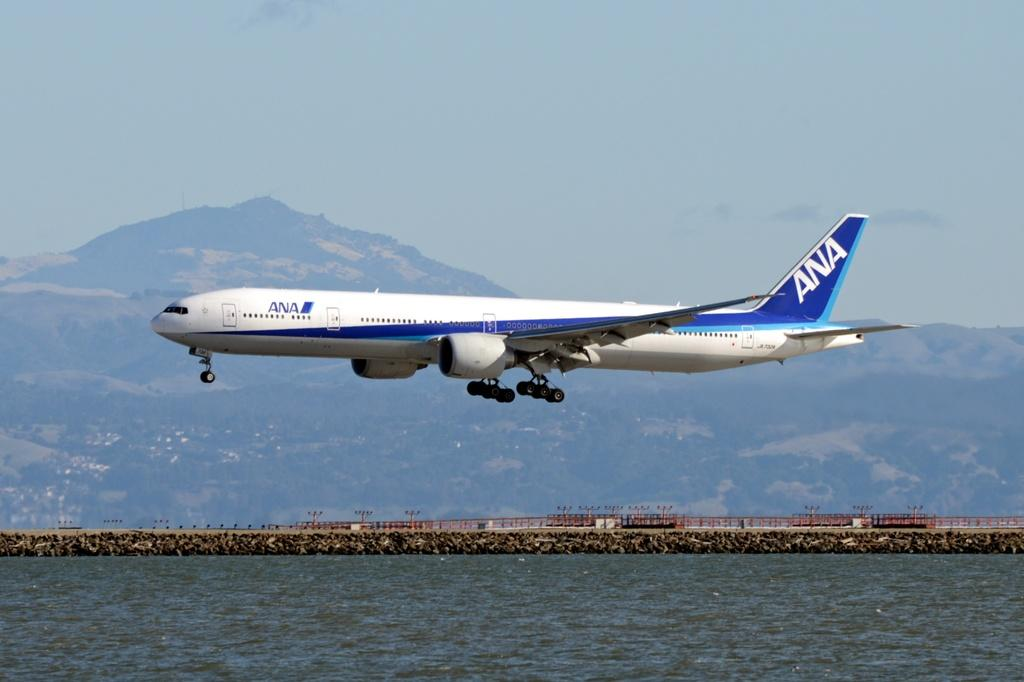<image>
Describe the image concisely. A blue and white Ana Airlines airplane makes its landing crossing over a river 